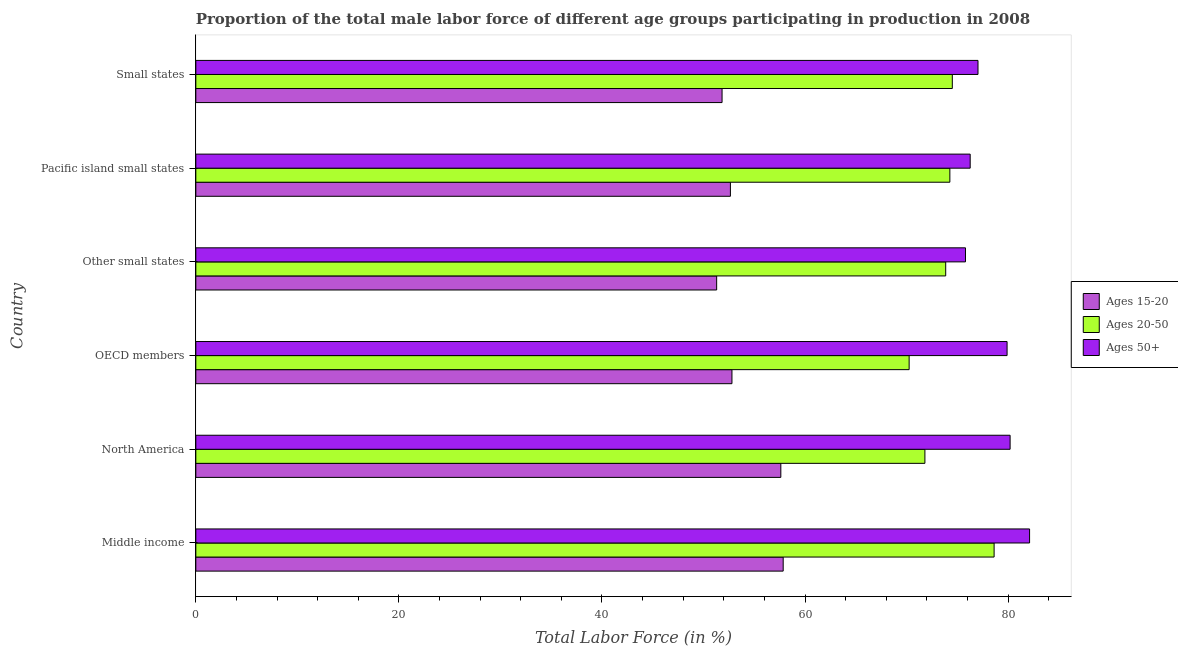How many different coloured bars are there?
Ensure brevity in your answer.  3. Are the number of bars per tick equal to the number of legend labels?
Offer a terse response. Yes. Are the number of bars on each tick of the Y-axis equal?
Ensure brevity in your answer.  Yes. How many bars are there on the 4th tick from the bottom?
Your response must be concise. 3. In how many cases, is the number of bars for a given country not equal to the number of legend labels?
Your response must be concise. 0. What is the percentage of male labor force above age 50 in OECD members?
Provide a succinct answer. 79.9. Across all countries, what is the maximum percentage of male labor force within the age group 15-20?
Make the answer very short. 57.85. Across all countries, what is the minimum percentage of male labor force within the age group 20-50?
Provide a short and direct response. 70.25. In which country was the percentage of male labor force within the age group 20-50 minimum?
Your answer should be compact. OECD members. What is the total percentage of male labor force above age 50 in the graph?
Keep it short and to the point. 471.3. What is the difference between the percentage of male labor force within the age group 20-50 in Middle income and that in North America?
Your answer should be very brief. 6.82. What is the difference between the percentage of male labor force within the age group 15-20 in Small states and the percentage of male labor force within the age group 20-50 in Other small states?
Keep it short and to the point. -22.03. What is the average percentage of male labor force above age 50 per country?
Provide a short and direct response. 78.55. What is the difference between the percentage of male labor force within the age group 20-50 and percentage of male labor force within the age group 15-20 in Middle income?
Provide a short and direct response. 20.77. In how many countries, is the percentage of male labor force within the age group 20-50 greater than 72 %?
Give a very brief answer. 4. What is the ratio of the percentage of male labor force within the age group 15-20 in Middle income to that in Pacific island small states?
Your answer should be very brief. 1.1. Is the percentage of male labor force within the age group 20-50 in North America less than that in Small states?
Give a very brief answer. Yes. What is the difference between the highest and the second highest percentage of male labor force within the age group 15-20?
Give a very brief answer. 0.23. What is the difference between the highest and the lowest percentage of male labor force within the age group 20-50?
Give a very brief answer. 8.37. In how many countries, is the percentage of male labor force above age 50 greater than the average percentage of male labor force above age 50 taken over all countries?
Provide a succinct answer. 3. What does the 3rd bar from the top in Middle income represents?
Your response must be concise. Ages 15-20. What does the 1st bar from the bottom in OECD members represents?
Your answer should be very brief. Ages 15-20. Is it the case that in every country, the sum of the percentage of male labor force within the age group 15-20 and percentage of male labor force within the age group 20-50 is greater than the percentage of male labor force above age 50?
Provide a short and direct response. Yes. How many countries are there in the graph?
Give a very brief answer. 6. Does the graph contain any zero values?
Give a very brief answer. No. Does the graph contain grids?
Provide a short and direct response. No. Where does the legend appear in the graph?
Ensure brevity in your answer.  Center right. What is the title of the graph?
Keep it short and to the point. Proportion of the total male labor force of different age groups participating in production in 2008. What is the Total Labor Force (in %) in Ages 15-20 in Middle income?
Provide a succinct answer. 57.85. What is the Total Labor Force (in %) in Ages 20-50 in Middle income?
Your response must be concise. 78.62. What is the Total Labor Force (in %) in Ages 50+ in Middle income?
Keep it short and to the point. 82.11. What is the Total Labor Force (in %) of Ages 15-20 in North America?
Your answer should be compact. 57.61. What is the Total Labor Force (in %) of Ages 20-50 in North America?
Ensure brevity in your answer.  71.8. What is the Total Labor Force (in %) of Ages 50+ in North America?
Offer a very short reply. 80.19. What is the Total Labor Force (in %) of Ages 15-20 in OECD members?
Offer a terse response. 52.8. What is the Total Labor Force (in %) in Ages 20-50 in OECD members?
Make the answer very short. 70.25. What is the Total Labor Force (in %) of Ages 50+ in OECD members?
Give a very brief answer. 79.9. What is the Total Labor Force (in %) of Ages 15-20 in Other small states?
Provide a succinct answer. 51.29. What is the Total Labor Force (in %) in Ages 20-50 in Other small states?
Give a very brief answer. 73.85. What is the Total Labor Force (in %) of Ages 50+ in Other small states?
Ensure brevity in your answer.  75.8. What is the Total Labor Force (in %) in Ages 15-20 in Pacific island small states?
Offer a very short reply. 52.65. What is the Total Labor Force (in %) in Ages 20-50 in Pacific island small states?
Offer a terse response. 74.26. What is the Total Labor Force (in %) of Ages 50+ in Pacific island small states?
Make the answer very short. 76.26. What is the Total Labor Force (in %) in Ages 15-20 in Small states?
Provide a short and direct response. 51.83. What is the Total Labor Force (in %) of Ages 20-50 in Small states?
Offer a very short reply. 74.5. What is the Total Labor Force (in %) in Ages 50+ in Small states?
Ensure brevity in your answer.  77.03. Across all countries, what is the maximum Total Labor Force (in %) of Ages 15-20?
Keep it short and to the point. 57.85. Across all countries, what is the maximum Total Labor Force (in %) in Ages 20-50?
Offer a very short reply. 78.62. Across all countries, what is the maximum Total Labor Force (in %) of Ages 50+?
Your response must be concise. 82.11. Across all countries, what is the minimum Total Labor Force (in %) in Ages 15-20?
Your answer should be very brief. 51.29. Across all countries, what is the minimum Total Labor Force (in %) in Ages 20-50?
Provide a short and direct response. 70.25. Across all countries, what is the minimum Total Labor Force (in %) in Ages 50+?
Make the answer very short. 75.8. What is the total Total Labor Force (in %) of Ages 15-20 in the graph?
Keep it short and to the point. 324.03. What is the total Total Labor Force (in %) in Ages 20-50 in the graph?
Give a very brief answer. 443.28. What is the total Total Labor Force (in %) of Ages 50+ in the graph?
Your answer should be very brief. 471.3. What is the difference between the Total Labor Force (in %) of Ages 15-20 in Middle income and that in North America?
Your answer should be compact. 0.23. What is the difference between the Total Labor Force (in %) of Ages 20-50 in Middle income and that in North America?
Keep it short and to the point. 6.82. What is the difference between the Total Labor Force (in %) in Ages 50+ in Middle income and that in North America?
Ensure brevity in your answer.  1.92. What is the difference between the Total Labor Force (in %) of Ages 15-20 in Middle income and that in OECD members?
Your response must be concise. 5.04. What is the difference between the Total Labor Force (in %) of Ages 20-50 in Middle income and that in OECD members?
Give a very brief answer. 8.37. What is the difference between the Total Labor Force (in %) of Ages 50+ in Middle income and that in OECD members?
Provide a short and direct response. 2.21. What is the difference between the Total Labor Force (in %) in Ages 15-20 in Middle income and that in Other small states?
Make the answer very short. 6.55. What is the difference between the Total Labor Force (in %) in Ages 20-50 in Middle income and that in Other small states?
Offer a terse response. 4.77. What is the difference between the Total Labor Force (in %) of Ages 50+ in Middle income and that in Other small states?
Your answer should be compact. 6.31. What is the difference between the Total Labor Force (in %) in Ages 15-20 in Middle income and that in Pacific island small states?
Your answer should be compact. 5.2. What is the difference between the Total Labor Force (in %) in Ages 20-50 in Middle income and that in Pacific island small states?
Make the answer very short. 4.36. What is the difference between the Total Labor Force (in %) of Ages 50+ in Middle income and that in Pacific island small states?
Provide a short and direct response. 5.85. What is the difference between the Total Labor Force (in %) in Ages 15-20 in Middle income and that in Small states?
Give a very brief answer. 6.02. What is the difference between the Total Labor Force (in %) of Ages 20-50 in Middle income and that in Small states?
Your answer should be very brief. 4.12. What is the difference between the Total Labor Force (in %) of Ages 50+ in Middle income and that in Small states?
Ensure brevity in your answer.  5.08. What is the difference between the Total Labor Force (in %) of Ages 15-20 in North America and that in OECD members?
Your response must be concise. 4.81. What is the difference between the Total Labor Force (in %) of Ages 20-50 in North America and that in OECD members?
Make the answer very short. 1.55. What is the difference between the Total Labor Force (in %) of Ages 50+ in North America and that in OECD members?
Make the answer very short. 0.3. What is the difference between the Total Labor Force (in %) of Ages 15-20 in North America and that in Other small states?
Your response must be concise. 6.32. What is the difference between the Total Labor Force (in %) in Ages 20-50 in North America and that in Other small states?
Provide a short and direct response. -2.05. What is the difference between the Total Labor Force (in %) in Ages 50+ in North America and that in Other small states?
Give a very brief answer. 4.4. What is the difference between the Total Labor Force (in %) in Ages 15-20 in North America and that in Pacific island small states?
Your response must be concise. 4.97. What is the difference between the Total Labor Force (in %) in Ages 20-50 in North America and that in Pacific island small states?
Provide a succinct answer. -2.46. What is the difference between the Total Labor Force (in %) of Ages 50+ in North America and that in Pacific island small states?
Provide a succinct answer. 3.93. What is the difference between the Total Labor Force (in %) in Ages 15-20 in North America and that in Small states?
Keep it short and to the point. 5.79. What is the difference between the Total Labor Force (in %) in Ages 20-50 in North America and that in Small states?
Your answer should be very brief. -2.7. What is the difference between the Total Labor Force (in %) in Ages 50+ in North America and that in Small states?
Offer a very short reply. 3.16. What is the difference between the Total Labor Force (in %) in Ages 15-20 in OECD members and that in Other small states?
Provide a short and direct response. 1.51. What is the difference between the Total Labor Force (in %) of Ages 20-50 in OECD members and that in Other small states?
Your response must be concise. -3.6. What is the difference between the Total Labor Force (in %) of Ages 50+ in OECD members and that in Other small states?
Keep it short and to the point. 4.1. What is the difference between the Total Labor Force (in %) in Ages 15-20 in OECD members and that in Pacific island small states?
Make the answer very short. 0.15. What is the difference between the Total Labor Force (in %) of Ages 20-50 in OECD members and that in Pacific island small states?
Your answer should be compact. -4.01. What is the difference between the Total Labor Force (in %) in Ages 50+ in OECD members and that in Pacific island small states?
Provide a short and direct response. 3.63. What is the difference between the Total Labor Force (in %) in Ages 15-20 in OECD members and that in Small states?
Give a very brief answer. 0.98. What is the difference between the Total Labor Force (in %) of Ages 20-50 in OECD members and that in Small states?
Keep it short and to the point. -4.25. What is the difference between the Total Labor Force (in %) in Ages 50+ in OECD members and that in Small states?
Provide a short and direct response. 2.86. What is the difference between the Total Labor Force (in %) in Ages 15-20 in Other small states and that in Pacific island small states?
Your response must be concise. -1.35. What is the difference between the Total Labor Force (in %) of Ages 20-50 in Other small states and that in Pacific island small states?
Offer a very short reply. -0.41. What is the difference between the Total Labor Force (in %) of Ages 50+ in Other small states and that in Pacific island small states?
Offer a very short reply. -0.46. What is the difference between the Total Labor Force (in %) of Ages 15-20 in Other small states and that in Small states?
Your answer should be very brief. -0.53. What is the difference between the Total Labor Force (in %) of Ages 20-50 in Other small states and that in Small states?
Offer a terse response. -0.65. What is the difference between the Total Labor Force (in %) of Ages 50+ in Other small states and that in Small states?
Your answer should be very brief. -1.23. What is the difference between the Total Labor Force (in %) in Ages 15-20 in Pacific island small states and that in Small states?
Give a very brief answer. 0.82. What is the difference between the Total Labor Force (in %) in Ages 20-50 in Pacific island small states and that in Small states?
Your response must be concise. -0.24. What is the difference between the Total Labor Force (in %) of Ages 50+ in Pacific island small states and that in Small states?
Make the answer very short. -0.77. What is the difference between the Total Labor Force (in %) of Ages 15-20 in Middle income and the Total Labor Force (in %) of Ages 20-50 in North America?
Ensure brevity in your answer.  -13.96. What is the difference between the Total Labor Force (in %) of Ages 15-20 in Middle income and the Total Labor Force (in %) of Ages 50+ in North America?
Offer a terse response. -22.35. What is the difference between the Total Labor Force (in %) of Ages 20-50 in Middle income and the Total Labor Force (in %) of Ages 50+ in North America?
Ensure brevity in your answer.  -1.58. What is the difference between the Total Labor Force (in %) of Ages 15-20 in Middle income and the Total Labor Force (in %) of Ages 20-50 in OECD members?
Keep it short and to the point. -12.4. What is the difference between the Total Labor Force (in %) in Ages 15-20 in Middle income and the Total Labor Force (in %) in Ages 50+ in OECD members?
Ensure brevity in your answer.  -22.05. What is the difference between the Total Labor Force (in %) of Ages 20-50 in Middle income and the Total Labor Force (in %) of Ages 50+ in OECD members?
Your response must be concise. -1.28. What is the difference between the Total Labor Force (in %) in Ages 15-20 in Middle income and the Total Labor Force (in %) in Ages 20-50 in Other small states?
Ensure brevity in your answer.  -16.01. What is the difference between the Total Labor Force (in %) of Ages 15-20 in Middle income and the Total Labor Force (in %) of Ages 50+ in Other small states?
Keep it short and to the point. -17.95. What is the difference between the Total Labor Force (in %) in Ages 20-50 in Middle income and the Total Labor Force (in %) in Ages 50+ in Other small states?
Make the answer very short. 2.82. What is the difference between the Total Labor Force (in %) of Ages 15-20 in Middle income and the Total Labor Force (in %) of Ages 20-50 in Pacific island small states?
Your answer should be compact. -16.41. What is the difference between the Total Labor Force (in %) in Ages 15-20 in Middle income and the Total Labor Force (in %) in Ages 50+ in Pacific island small states?
Keep it short and to the point. -18.42. What is the difference between the Total Labor Force (in %) in Ages 20-50 in Middle income and the Total Labor Force (in %) in Ages 50+ in Pacific island small states?
Your response must be concise. 2.36. What is the difference between the Total Labor Force (in %) of Ages 15-20 in Middle income and the Total Labor Force (in %) of Ages 20-50 in Small states?
Your answer should be very brief. -16.66. What is the difference between the Total Labor Force (in %) of Ages 15-20 in Middle income and the Total Labor Force (in %) of Ages 50+ in Small states?
Ensure brevity in your answer.  -19.19. What is the difference between the Total Labor Force (in %) of Ages 20-50 in Middle income and the Total Labor Force (in %) of Ages 50+ in Small states?
Keep it short and to the point. 1.59. What is the difference between the Total Labor Force (in %) in Ages 15-20 in North America and the Total Labor Force (in %) in Ages 20-50 in OECD members?
Provide a short and direct response. -12.64. What is the difference between the Total Labor Force (in %) of Ages 15-20 in North America and the Total Labor Force (in %) of Ages 50+ in OECD members?
Your answer should be very brief. -22.28. What is the difference between the Total Labor Force (in %) in Ages 20-50 in North America and the Total Labor Force (in %) in Ages 50+ in OECD members?
Ensure brevity in your answer.  -8.09. What is the difference between the Total Labor Force (in %) in Ages 15-20 in North America and the Total Labor Force (in %) in Ages 20-50 in Other small states?
Make the answer very short. -16.24. What is the difference between the Total Labor Force (in %) of Ages 15-20 in North America and the Total Labor Force (in %) of Ages 50+ in Other small states?
Ensure brevity in your answer.  -18.18. What is the difference between the Total Labor Force (in %) of Ages 20-50 in North America and the Total Labor Force (in %) of Ages 50+ in Other small states?
Ensure brevity in your answer.  -4. What is the difference between the Total Labor Force (in %) of Ages 15-20 in North America and the Total Labor Force (in %) of Ages 20-50 in Pacific island small states?
Keep it short and to the point. -16.65. What is the difference between the Total Labor Force (in %) in Ages 15-20 in North America and the Total Labor Force (in %) in Ages 50+ in Pacific island small states?
Provide a succinct answer. -18.65. What is the difference between the Total Labor Force (in %) in Ages 20-50 in North America and the Total Labor Force (in %) in Ages 50+ in Pacific island small states?
Your answer should be very brief. -4.46. What is the difference between the Total Labor Force (in %) of Ages 15-20 in North America and the Total Labor Force (in %) of Ages 20-50 in Small states?
Provide a short and direct response. -16.89. What is the difference between the Total Labor Force (in %) in Ages 15-20 in North America and the Total Labor Force (in %) in Ages 50+ in Small states?
Keep it short and to the point. -19.42. What is the difference between the Total Labor Force (in %) in Ages 20-50 in North America and the Total Labor Force (in %) in Ages 50+ in Small states?
Ensure brevity in your answer.  -5.23. What is the difference between the Total Labor Force (in %) in Ages 15-20 in OECD members and the Total Labor Force (in %) in Ages 20-50 in Other small states?
Make the answer very short. -21.05. What is the difference between the Total Labor Force (in %) in Ages 15-20 in OECD members and the Total Labor Force (in %) in Ages 50+ in Other small states?
Ensure brevity in your answer.  -23. What is the difference between the Total Labor Force (in %) of Ages 20-50 in OECD members and the Total Labor Force (in %) of Ages 50+ in Other small states?
Your response must be concise. -5.55. What is the difference between the Total Labor Force (in %) of Ages 15-20 in OECD members and the Total Labor Force (in %) of Ages 20-50 in Pacific island small states?
Give a very brief answer. -21.46. What is the difference between the Total Labor Force (in %) in Ages 15-20 in OECD members and the Total Labor Force (in %) in Ages 50+ in Pacific island small states?
Give a very brief answer. -23.46. What is the difference between the Total Labor Force (in %) of Ages 20-50 in OECD members and the Total Labor Force (in %) of Ages 50+ in Pacific island small states?
Your response must be concise. -6.01. What is the difference between the Total Labor Force (in %) of Ages 15-20 in OECD members and the Total Labor Force (in %) of Ages 20-50 in Small states?
Your answer should be compact. -21.7. What is the difference between the Total Labor Force (in %) in Ages 15-20 in OECD members and the Total Labor Force (in %) in Ages 50+ in Small states?
Your answer should be very brief. -24.23. What is the difference between the Total Labor Force (in %) in Ages 20-50 in OECD members and the Total Labor Force (in %) in Ages 50+ in Small states?
Provide a short and direct response. -6.78. What is the difference between the Total Labor Force (in %) in Ages 15-20 in Other small states and the Total Labor Force (in %) in Ages 20-50 in Pacific island small states?
Give a very brief answer. -22.97. What is the difference between the Total Labor Force (in %) of Ages 15-20 in Other small states and the Total Labor Force (in %) of Ages 50+ in Pacific island small states?
Give a very brief answer. -24.97. What is the difference between the Total Labor Force (in %) of Ages 20-50 in Other small states and the Total Labor Force (in %) of Ages 50+ in Pacific island small states?
Ensure brevity in your answer.  -2.41. What is the difference between the Total Labor Force (in %) of Ages 15-20 in Other small states and the Total Labor Force (in %) of Ages 20-50 in Small states?
Ensure brevity in your answer.  -23.21. What is the difference between the Total Labor Force (in %) in Ages 15-20 in Other small states and the Total Labor Force (in %) in Ages 50+ in Small states?
Make the answer very short. -25.74. What is the difference between the Total Labor Force (in %) of Ages 20-50 in Other small states and the Total Labor Force (in %) of Ages 50+ in Small states?
Your answer should be very brief. -3.18. What is the difference between the Total Labor Force (in %) in Ages 15-20 in Pacific island small states and the Total Labor Force (in %) in Ages 20-50 in Small states?
Make the answer very short. -21.85. What is the difference between the Total Labor Force (in %) in Ages 15-20 in Pacific island small states and the Total Labor Force (in %) in Ages 50+ in Small states?
Your response must be concise. -24.38. What is the difference between the Total Labor Force (in %) of Ages 20-50 in Pacific island small states and the Total Labor Force (in %) of Ages 50+ in Small states?
Provide a succinct answer. -2.77. What is the average Total Labor Force (in %) of Ages 15-20 per country?
Offer a terse response. 54. What is the average Total Labor Force (in %) of Ages 20-50 per country?
Provide a succinct answer. 73.88. What is the average Total Labor Force (in %) of Ages 50+ per country?
Your response must be concise. 78.55. What is the difference between the Total Labor Force (in %) in Ages 15-20 and Total Labor Force (in %) in Ages 20-50 in Middle income?
Offer a very short reply. -20.77. What is the difference between the Total Labor Force (in %) of Ages 15-20 and Total Labor Force (in %) of Ages 50+ in Middle income?
Offer a terse response. -24.27. What is the difference between the Total Labor Force (in %) in Ages 20-50 and Total Labor Force (in %) in Ages 50+ in Middle income?
Provide a succinct answer. -3.49. What is the difference between the Total Labor Force (in %) of Ages 15-20 and Total Labor Force (in %) of Ages 20-50 in North America?
Offer a very short reply. -14.19. What is the difference between the Total Labor Force (in %) in Ages 15-20 and Total Labor Force (in %) in Ages 50+ in North America?
Offer a very short reply. -22.58. What is the difference between the Total Labor Force (in %) in Ages 20-50 and Total Labor Force (in %) in Ages 50+ in North America?
Make the answer very short. -8.39. What is the difference between the Total Labor Force (in %) in Ages 15-20 and Total Labor Force (in %) in Ages 20-50 in OECD members?
Offer a very short reply. -17.45. What is the difference between the Total Labor Force (in %) in Ages 15-20 and Total Labor Force (in %) in Ages 50+ in OECD members?
Give a very brief answer. -27.1. What is the difference between the Total Labor Force (in %) in Ages 20-50 and Total Labor Force (in %) in Ages 50+ in OECD members?
Provide a succinct answer. -9.65. What is the difference between the Total Labor Force (in %) of Ages 15-20 and Total Labor Force (in %) of Ages 20-50 in Other small states?
Provide a short and direct response. -22.56. What is the difference between the Total Labor Force (in %) in Ages 15-20 and Total Labor Force (in %) in Ages 50+ in Other small states?
Make the answer very short. -24.51. What is the difference between the Total Labor Force (in %) of Ages 20-50 and Total Labor Force (in %) of Ages 50+ in Other small states?
Offer a very short reply. -1.95. What is the difference between the Total Labor Force (in %) in Ages 15-20 and Total Labor Force (in %) in Ages 20-50 in Pacific island small states?
Your answer should be compact. -21.61. What is the difference between the Total Labor Force (in %) of Ages 15-20 and Total Labor Force (in %) of Ages 50+ in Pacific island small states?
Your answer should be very brief. -23.61. What is the difference between the Total Labor Force (in %) in Ages 20-50 and Total Labor Force (in %) in Ages 50+ in Pacific island small states?
Offer a very short reply. -2. What is the difference between the Total Labor Force (in %) in Ages 15-20 and Total Labor Force (in %) in Ages 20-50 in Small states?
Offer a terse response. -22.68. What is the difference between the Total Labor Force (in %) in Ages 15-20 and Total Labor Force (in %) in Ages 50+ in Small states?
Give a very brief answer. -25.21. What is the difference between the Total Labor Force (in %) of Ages 20-50 and Total Labor Force (in %) of Ages 50+ in Small states?
Provide a short and direct response. -2.53. What is the ratio of the Total Labor Force (in %) of Ages 20-50 in Middle income to that in North America?
Offer a very short reply. 1.09. What is the ratio of the Total Labor Force (in %) in Ages 50+ in Middle income to that in North America?
Give a very brief answer. 1.02. What is the ratio of the Total Labor Force (in %) of Ages 15-20 in Middle income to that in OECD members?
Give a very brief answer. 1.1. What is the ratio of the Total Labor Force (in %) in Ages 20-50 in Middle income to that in OECD members?
Ensure brevity in your answer.  1.12. What is the ratio of the Total Labor Force (in %) of Ages 50+ in Middle income to that in OECD members?
Ensure brevity in your answer.  1.03. What is the ratio of the Total Labor Force (in %) of Ages 15-20 in Middle income to that in Other small states?
Offer a terse response. 1.13. What is the ratio of the Total Labor Force (in %) in Ages 20-50 in Middle income to that in Other small states?
Your response must be concise. 1.06. What is the ratio of the Total Labor Force (in %) in Ages 15-20 in Middle income to that in Pacific island small states?
Provide a succinct answer. 1.1. What is the ratio of the Total Labor Force (in %) of Ages 20-50 in Middle income to that in Pacific island small states?
Provide a succinct answer. 1.06. What is the ratio of the Total Labor Force (in %) of Ages 50+ in Middle income to that in Pacific island small states?
Ensure brevity in your answer.  1.08. What is the ratio of the Total Labor Force (in %) in Ages 15-20 in Middle income to that in Small states?
Provide a succinct answer. 1.12. What is the ratio of the Total Labor Force (in %) of Ages 20-50 in Middle income to that in Small states?
Offer a very short reply. 1.06. What is the ratio of the Total Labor Force (in %) in Ages 50+ in Middle income to that in Small states?
Offer a terse response. 1.07. What is the ratio of the Total Labor Force (in %) in Ages 15-20 in North America to that in OECD members?
Keep it short and to the point. 1.09. What is the ratio of the Total Labor Force (in %) of Ages 20-50 in North America to that in OECD members?
Your answer should be compact. 1.02. What is the ratio of the Total Labor Force (in %) of Ages 15-20 in North America to that in Other small states?
Your answer should be very brief. 1.12. What is the ratio of the Total Labor Force (in %) of Ages 20-50 in North America to that in Other small states?
Provide a succinct answer. 0.97. What is the ratio of the Total Labor Force (in %) in Ages 50+ in North America to that in Other small states?
Offer a terse response. 1.06. What is the ratio of the Total Labor Force (in %) of Ages 15-20 in North America to that in Pacific island small states?
Your answer should be compact. 1.09. What is the ratio of the Total Labor Force (in %) of Ages 20-50 in North America to that in Pacific island small states?
Your response must be concise. 0.97. What is the ratio of the Total Labor Force (in %) of Ages 50+ in North America to that in Pacific island small states?
Ensure brevity in your answer.  1.05. What is the ratio of the Total Labor Force (in %) of Ages 15-20 in North America to that in Small states?
Your answer should be very brief. 1.11. What is the ratio of the Total Labor Force (in %) of Ages 20-50 in North America to that in Small states?
Offer a very short reply. 0.96. What is the ratio of the Total Labor Force (in %) in Ages 50+ in North America to that in Small states?
Give a very brief answer. 1.04. What is the ratio of the Total Labor Force (in %) in Ages 15-20 in OECD members to that in Other small states?
Your response must be concise. 1.03. What is the ratio of the Total Labor Force (in %) of Ages 20-50 in OECD members to that in Other small states?
Your answer should be very brief. 0.95. What is the ratio of the Total Labor Force (in %) of Ages 50+ in OECD members to that in Other small states?
Offer a very short reply. 1.05. What is the ratio of the Total Labor Force (in %) in Ages 15-20 in OECD members to that in Pacific island small states?
Your answer should be very brief. 1. What is the ratio of the Total Labor Force (in %) in Ages 20-50 in OECD members to that in Pacific island small states?
Ensure brevity in your answer.  0.95. What is the ratio of the Total Labor Force (in %) of Ages 50+ in OECD members to that in Pacific island small states?
Give a very brief answer. 1.05. What is the ratio of the Total Labor Force (in %) in Ages 15-20 in OECD members to that in Small states?
Offer a terse response. 1.02. What is the ratio of the Total Labor Force (in %) of Ages 20-50 in OECD members to that in Small states?
Keep it short and to the point. 0.94. What is the ratio of the Total Labor Force (in %) in Ages 50+ in OECD members to that in Small states?
Keep it short and to the point. 1.04. What is the ratio of the Total Labor Force (in %) of Ages 15-20 in Other small states to that in Pacific island small states?
Make the answer very short. 0.97. What is the ratio of the Total Labor Force (in %) in Ages 20-50 in Other small states to that in Pacific island small states?
Provide a short and direct response. 0.99. What is the ratio of the Total Labor Force (in %) of Ages 20-50 in Other small states to that in Small states?
Provide a short and direct response. 0.99. What is the ratio of the Total Labor Force (in %) in Ages 15-20 in Pacific island small states to that in Small states?
Offer a very short reply. 1.02. What is the ratio of the Total Labor Force (in %) of Ages 50+ in Pacific island small states to that in Small states?
Provide a succinct answer. 0.99. What is the difference between the highest and the second highest Total Labor Force (in %) in Ages 15-20?
Your response must be concise. 0.23. What is the difference between the highest and the second highest Total Labor Force (in %) in Ages 20-50?
Keep it short and to the point. 4.12. What is the difference between the highest and the second highest Total Labor Force (in %) of Ages 50+?
Keep it short and to the point. 1.92. What is the difference between the highest and the lowest Total Labor Force (in %) in Ages 15-20?
Offer a very short reply. 6.55. What is the difference between the highest and the lowest Total Labor Force (in %) in Ages 20-50?
Keep it short and to the point. 8.37. What is the difference between the highest and the lowest Total Labor Force (in %) of Ages 50+?
Offer a terse response. 6.31. 